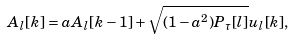<formula> <loc_0><loc_0><loc_500><loc_500>A _ { l } [ k ] = a A _ { l } [ k - 1 ] + \sqrt { ( 1 - a ^ { 2 } ) P _ { \tau } [ l ] } u _ { l } [ k ] ,</formula> 